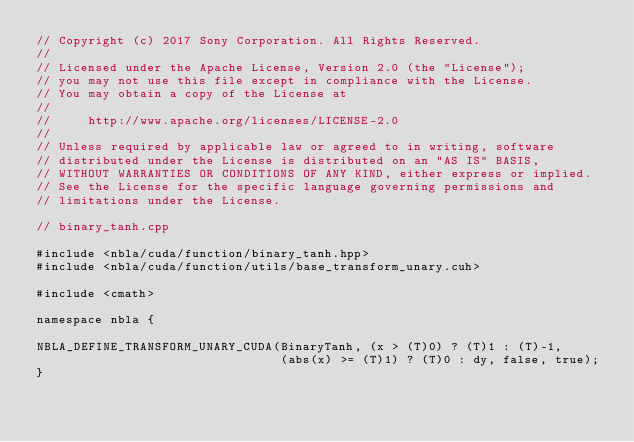Convert code to text. <code><loc_0><loc_0><loc_500><loc_500><_Cuda_>// Copyright (c) 2017 Sony Corporation. All Rights Reserved.
//
// Licensed under the Apache License, Version 2.0 (the "License");
// you may not use this file except in compliance with the License.
// You may obtain a copy of the License at
//
//     http://www.apache.org/licenses/LICENSE-2.0
//
// Unless required by applicable law or agreed to in writing, software
// distributed under the License is distributed on an "AS IS" BASIS,
// WITHOUT WARRANTIES OR CONDITIONS OF ANY KIND, either express or implied.
// See the License for the specific language governing permissions and
// limitations under the License.

// binary_tanh.cpp

#include <nbla/cuda/function/binary_tanh.hpp>
#include <nbla/cuda/function/utils/base_transform_unary.cuh>

#include <cmath>

namespace nbla {

NBLA_DEFINE_TRANSFORM_UNARY_CUDA(BinaryTanh, (x > (T)0) ? (T)1 : (T)-1,
                                 (abs(x) >= (T)1) ? (T)0 : dy, false, true);
}
</code> 